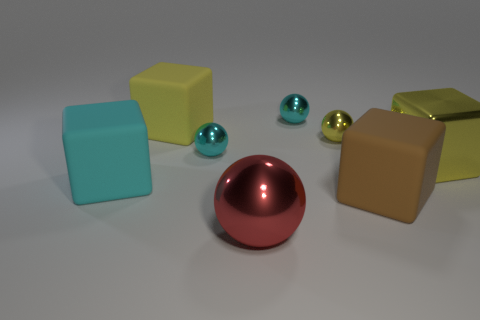What color is the large rubber thing left of the cube that is behind the yellow metal ball? The large rubber object, positioned to the left of the cube and behind the vibrant yellow metal ball, exhibits a cyan hue. This color adds a cool, calming tone to the mix of vivid and earthy colors presented in the scene, contributing to its visual harmony. 